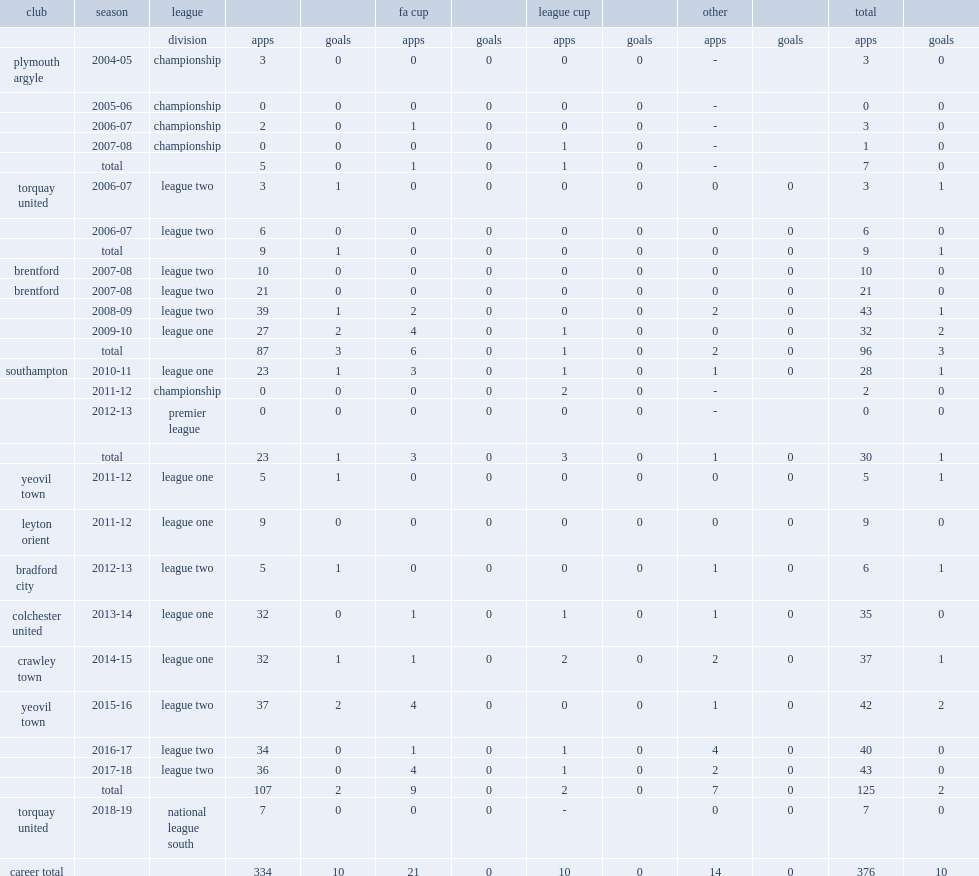How many appearances did ryan dickson make in brentford during 2007-08 season? 21.0. How many appearances did ryan dickson make during brentford's 2008-09 league two in a football league trophy? 43.0. 